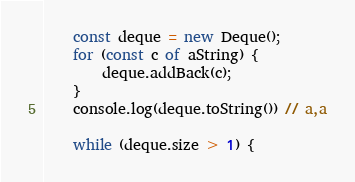Convert code to text. <code><loc_0><loc_0><loc_500><loc_500><_JavaScript_>    const deque = new Deque();
    for (const c of aString) {
        deque.addBack(c);
    }
    console.log(deque.toString()) // a,a

    while (deque.size > 1) {</code> 